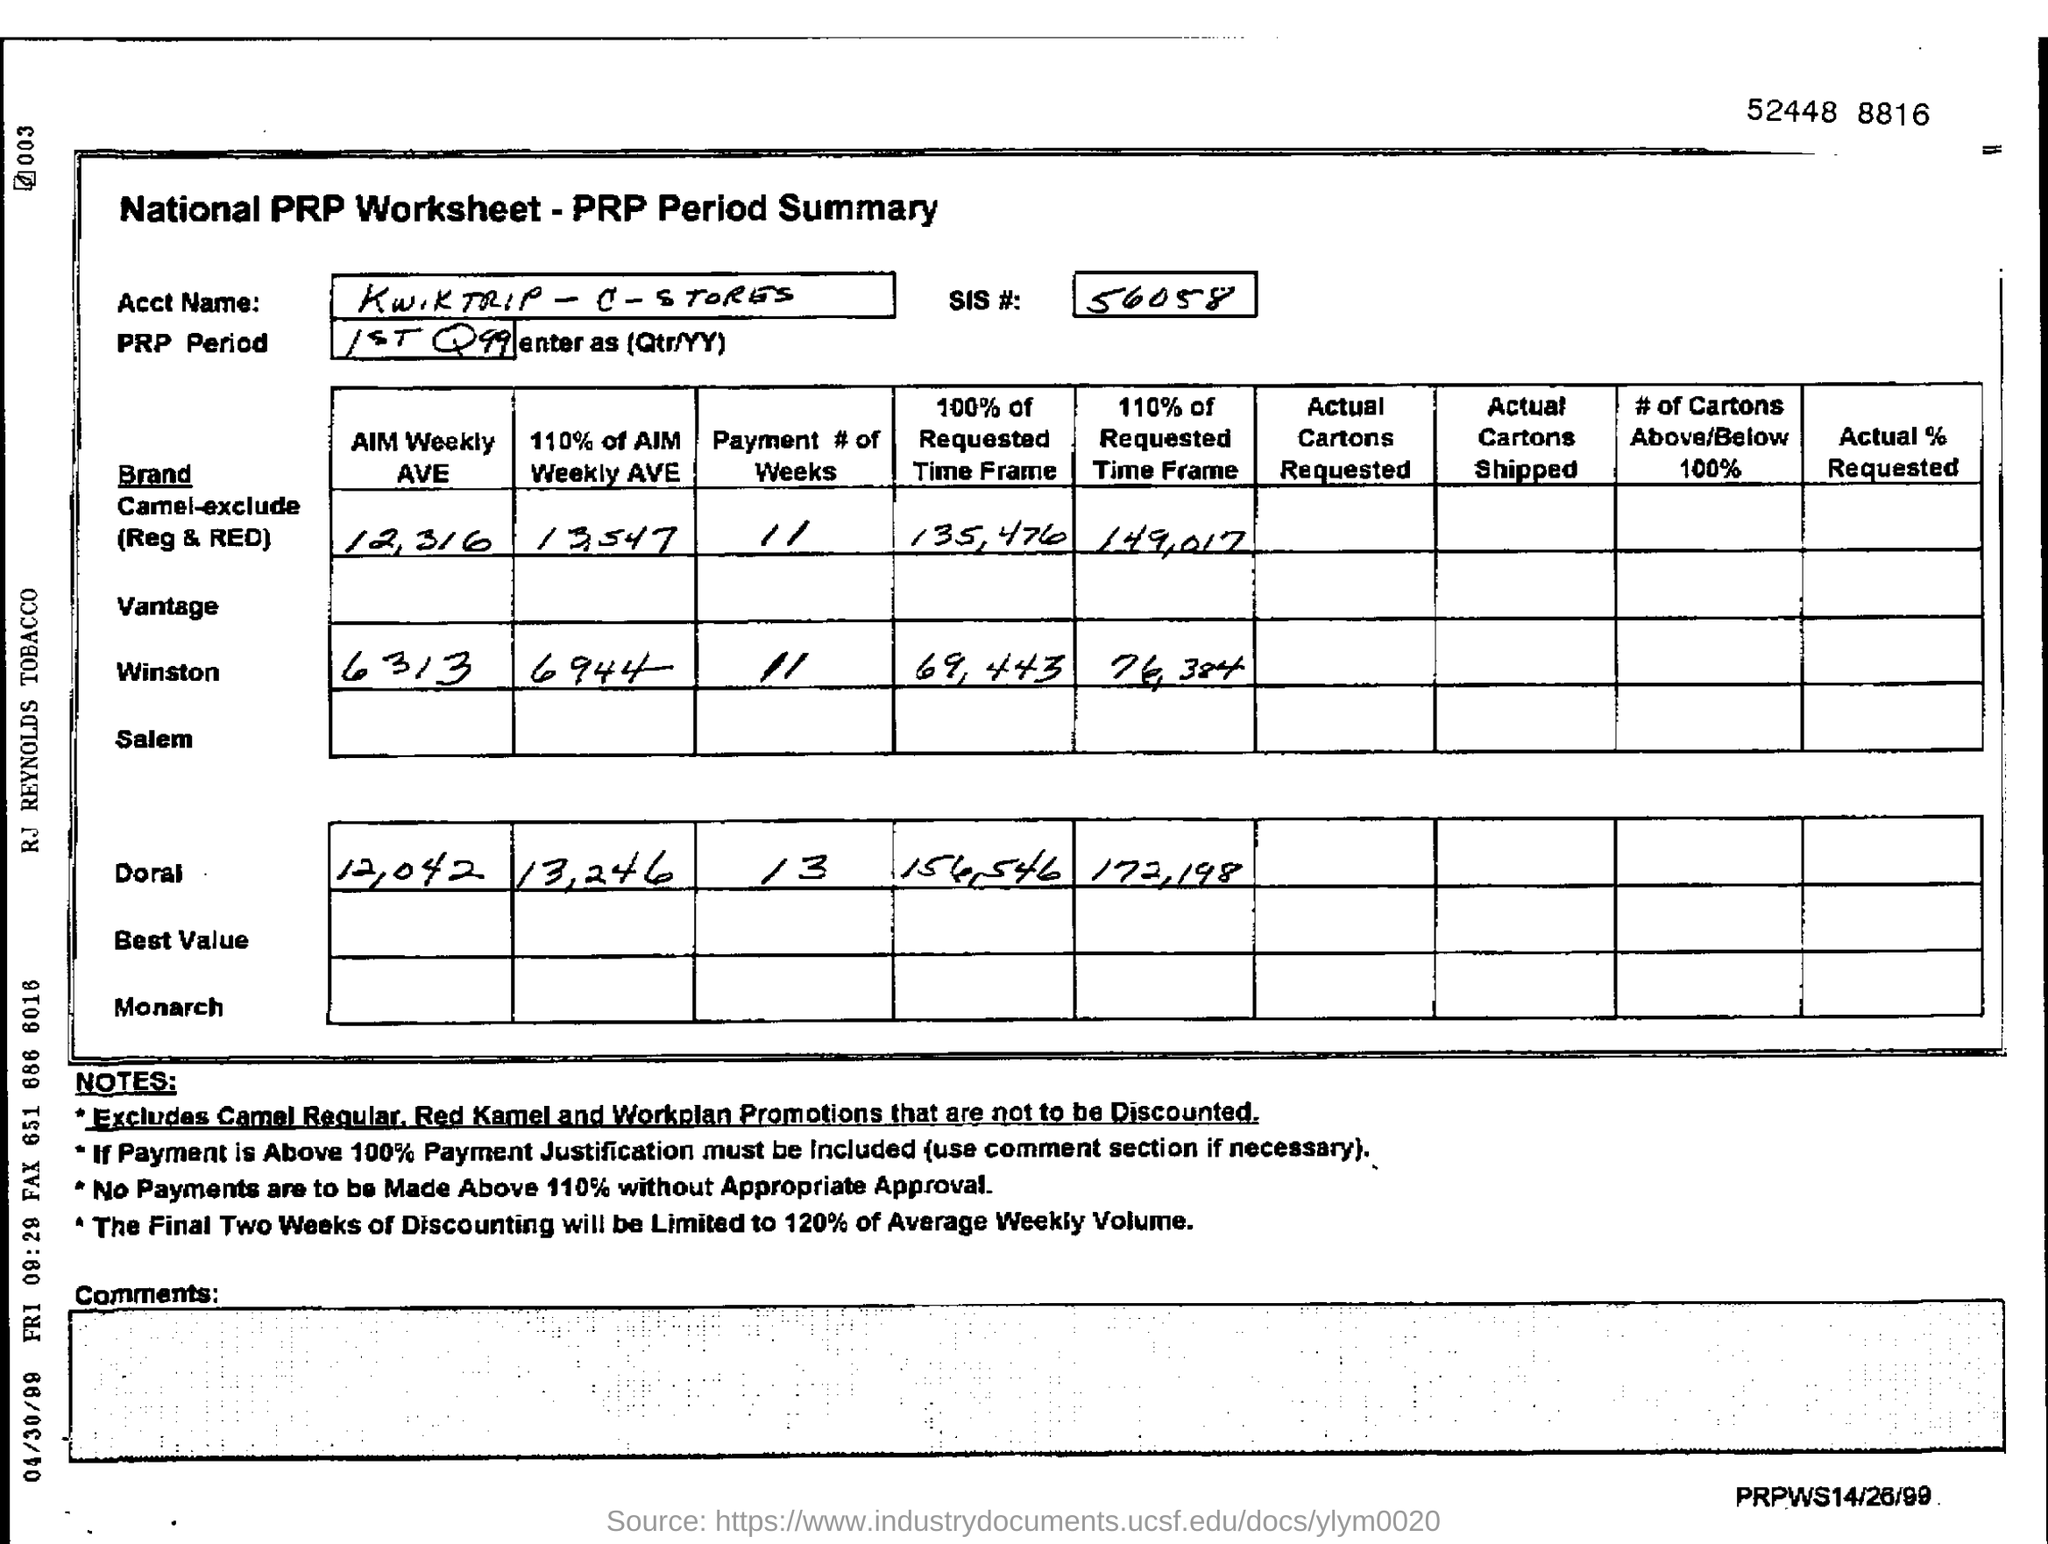Indicate a few pertinent items in this graphic. The SIS number is 56058. The average weekly expenditure of Winston, as reported by the AIM survey, is 6313. The SIS# mentioned in the form is 56058. 